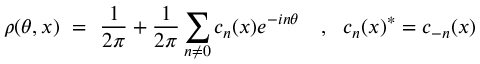Convert formula to latex. <formula><loc_0><loc_0><loc_500><loc_500>\rho ( \theta , x ) = \frac { 1 } { 2 \pi } + \frac { 1 } { 2 \pi } \sum _ { n \neq 0 } c _ { n } ( x ) e ^ { - i n \theta } , c _ { n } ( x ) ^ { * } = c _ { - n } ( x )</formula> 